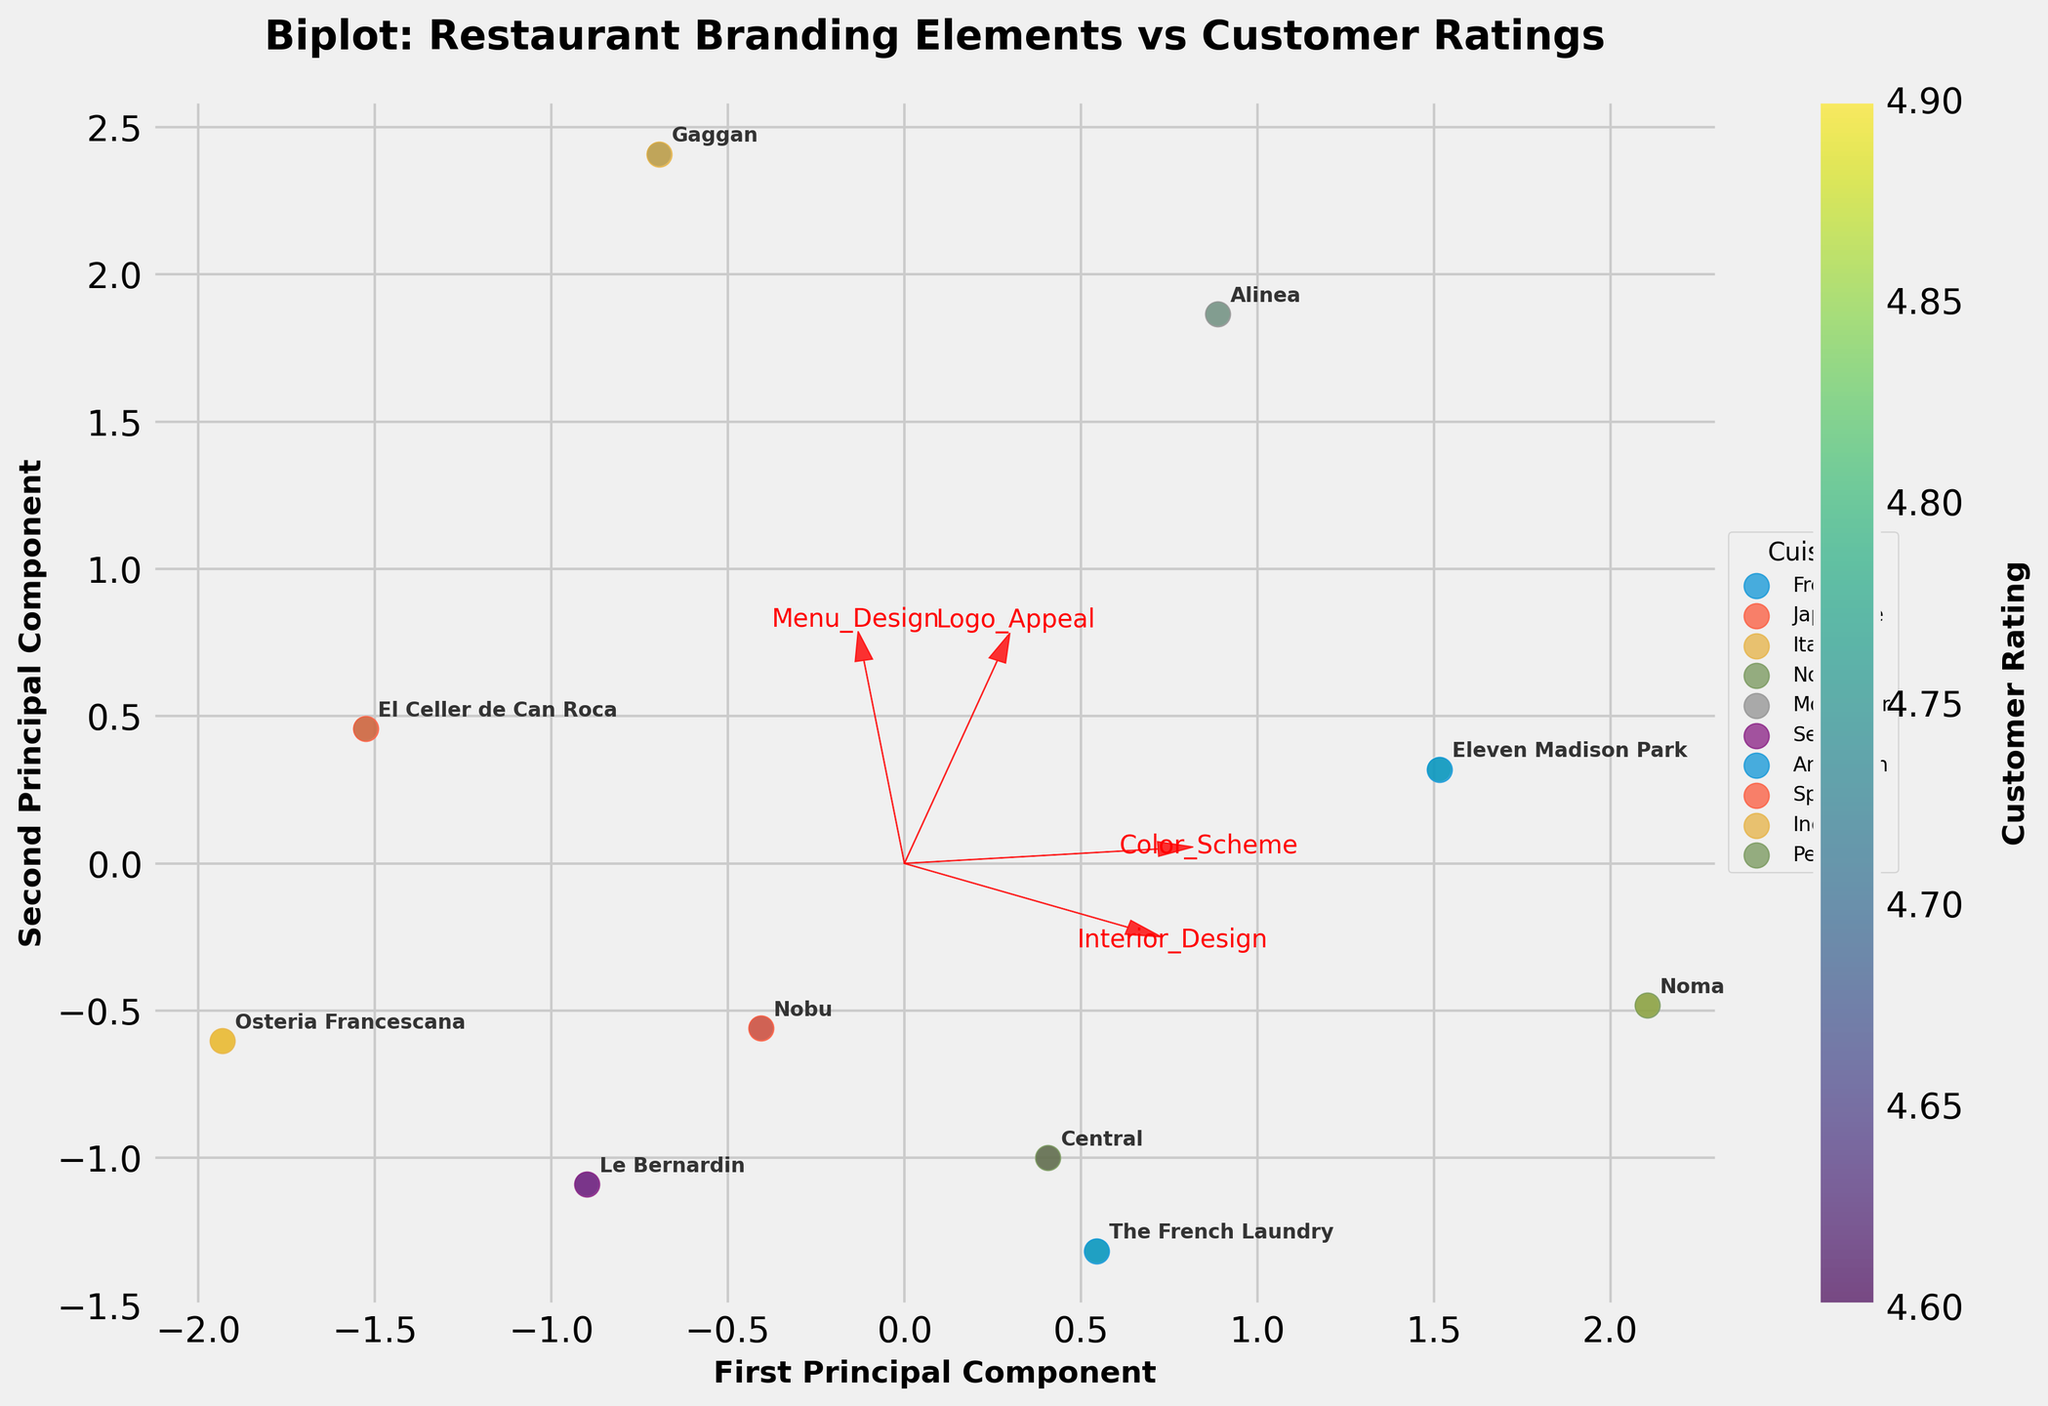What is the title of the plot? The title of the plot is always found at the top of the figure, usually in bigger and bold text to make it easily distinguishable. In this plot, the title is "Biplot: Restaurant Branding Elements vs Customer Ratings."
Answer: Biplot: Restaurant Branding Elements vs Customer Ratings How many principal components are represented in the biplot? The labels for the axes of a biplot typically indicate the number of principal components. In this plot, it shows "First Principal Component" for the x-axis and "Second Principal Component" for the y-axis. Therefore, two principal components are represented.
Answer: Two Which restaurant has the highest customer rating, and what is its cuisine? To find the restaurant with the highest customer rating, look at the colors of the points and check the color bar, where the highest value corresponds to the darkest color. "Osteria Francescana" and "Noma" both have high ratings of 4.9. Reading the respective point labels, "Osteria Francescana" is Italian cuisine, and "Noma" is Nordic cuisine.
Answer: Osteria Francescana, Italian; Noma, Nordic What branding element seems to have the strongest influence on the principal components? The feature vectors (red arrows) indicate the influence of each branding element. The longer the arrow, the stronger the influence. In this plot, "Interior_Design" and "Menu_Design" have the longest arrows, suggesting they have the strongest influence.
Answer: Interior_Design and Menu_Design Which restaurant's branding elements are closest to each other in the biplot? To determine which restaurant branding elements clustering together, look at the points that are nearest to each other on the plot. "Nobu" and "Eleven Madison Park" appear to be closest to each other in the biplot.
Answer: Nobu and Eleven Madison Park Are French and Japanese cuisines similarly rated by customers, and how can you tell? To compare French and Japanese cuisines, find "The French Laundry" (French) and "Nobu" (Japanese) on the plot. The colors indicate customer ratings. Both have ratings near 4.7-4.8, judging by their similar color intensity.
Answer: Similarly rated Which restaurant has the most appealing logo based on the vector directions and distances from the origin? The feature vector "Logo_Appeal" helps determine this. "Alinea" is closest to the direction where the "Logo_Appeal" arrow points and is farther away from the origin along this vector, suggesting it has the most appealing logo.
Answer: Alinea Between "Eleven Madison Park" and "El Celler de Can Roca," which has better interior design according to the biplot? By examining the direction and proximity to the "Interior_Design" vector, "Eleven Madison Park" is positioned closer to the arrow representing Interior_Design, suggesting it has better interior design.
Answer: Eleven Madison Park 